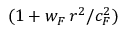Convert formula to latex. <formula><loc_0><loc_0><loc_500><loc_500>( 1 + w _ { F } \, r ^ { 2 } / c _ { F } ^ { 2 } )</formula> 